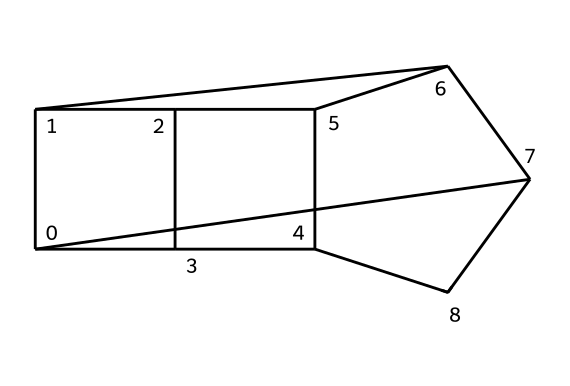What is the chemical name of the compound? The SMILES representation corresponds to adamantane, which is a hydrocarbon known for its cage-like structure.
Answer: adamantane How many carbon atoms are present in the structure? By analyzing the SMILES notation, we can see that it indicates multiple carbon rings, and specifically, there are 10 carbon atoms in adamantane.
Answer: 10 What type of molecular structure does this compound represent? Adamantane features a 3D structure with a stable cage-like configuration, distinguishing it from linear or branched hydrocarbons.
Answer: cage-like What is the total number of hydrogen atoms in this compound? Each carbon in adamantane is bonded to enough hydrogen atoms to satisfy its tetravalency, resulting in a total of 16 hydrogen atoms connected to the 10 carbon atoms.
Answer: 16 Which characteristic of adamantane contributes to its stability? The highly symmetrical and saturated cage structure of adamantane reduces strain on the chemical bonds, making it more stable compared to other hydrocarbons.
Answer: symmetry Is adamantane a saturated or unsaturated hydrocarbon? The absence of double or triple bonds in the structure, along with the full saturation of hydrogen atoms, classifies adamantane as a saturated hydrocarbon.
Answer: saturated 